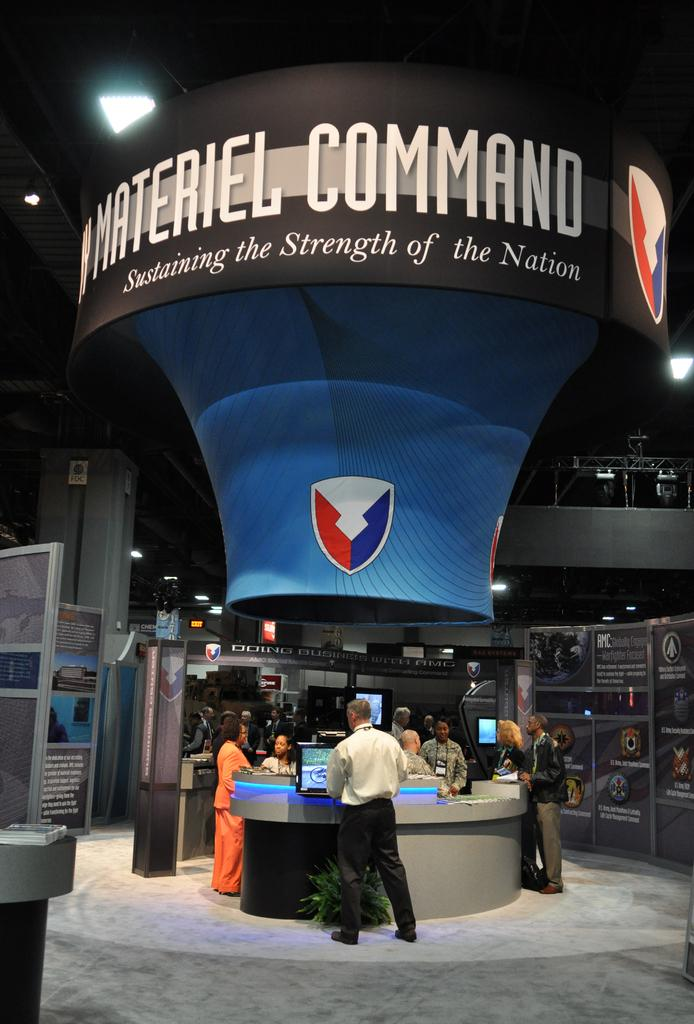What is happening in the image involving the persons and the table? There are persons around a table in the image, which suggests they might be engaged in an activity together. What is the object visible at the top of the image? There is a board visible at the top of the image. What can be seen in the background of the image? There is a wall in the background of the image, and there are posters on the wall. What language is being spoken by the persons around the table in the image? The provided facts do not mention any specific language being spoken in the image. How low is the board visible at the top of the image? The provided facts do not mention the height or position of the board in relation to the image. 